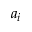<formula> <loc_0><loc_0><loc_500><loc_500>a _ { i }</formula> 